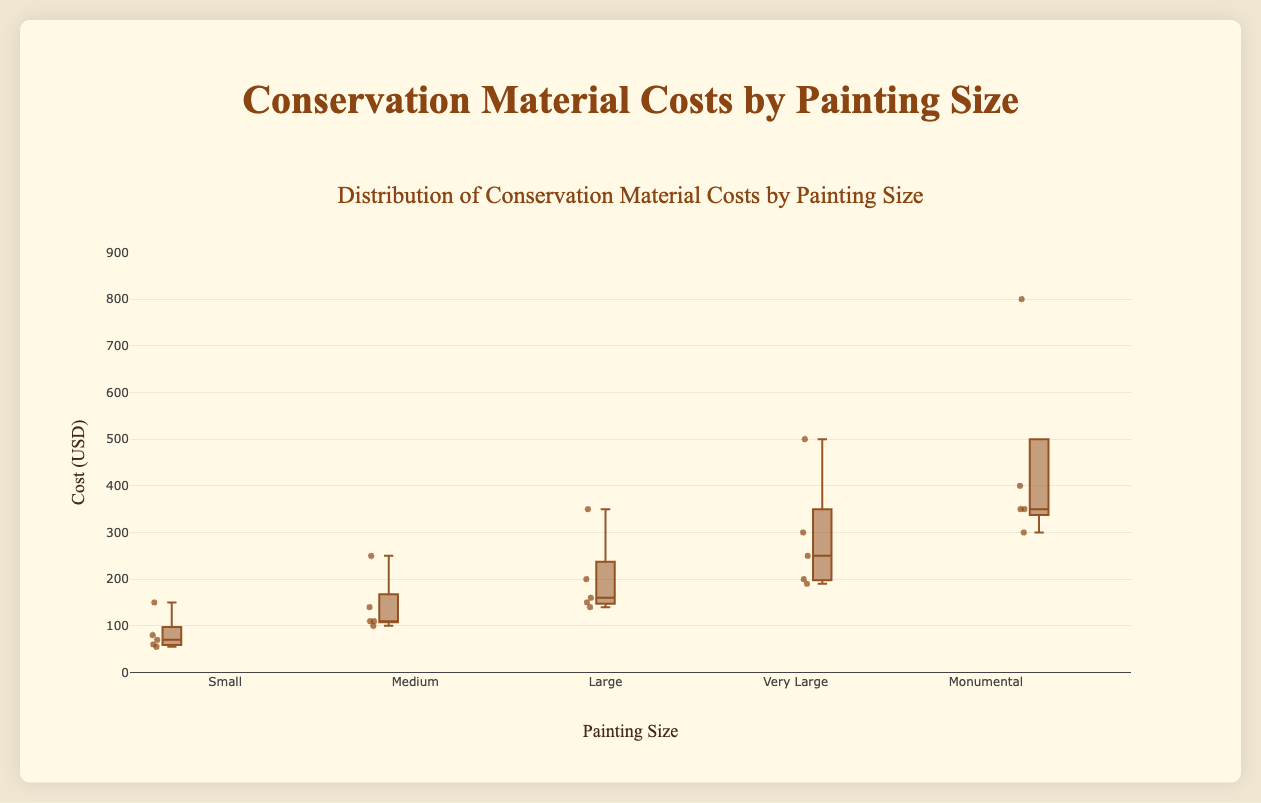How many painting sizes are displayed on the plot? The x-axis of the plot lists five different painting sizes: Small, Medium, Large, Very Large, and Monumental. Each size has its own corresponding box plot.
Answer: 5 Which painting size has the highest median conservation material cost? Looking at the horizontal line inside each box, which represents the median, the Monumental painting size has the highest median line compared to the other sizes.
Answer: Monumental What is the range of costs for the Small painting size? The range of a box plot is determined by the minimum and maximum values indicated by the lower and upper whiskers. For Small, the minimum cost is around 55 and the maximum cost is around 150.
Answer: 55 to 150 What is the general trend in material costs as the painting size increases? As the painting size increases from Small to Monumental, the median and overall range of conservation material costs also increase, showing a positive trend.
Answer: Costs increase with size Compare the interquartile range (IQR) of Medium and Very Large painting sizes. The IQR is the box part of the plot, representing the middle 50% of the data. For Medium, it ranges from about 100 to 250, which is 150. For Very Large, it ranges from about 190 to 500, which is 310.
Answer: Very Large's IQR is larger Which painting size has the most outliers? The number of individual points outside the whiskers of each box plot indicates the outliers. By observing the plot, the Medium painting size has the most outliers compared to other sizes.
Answer: Medium Is there a painting size where the cost does not vary much? By analyzing the height of the boxes and the distance between whiskers, the Small painting size has the shortest range and less variation in costs compared to other sizes.
Answer: Small What is the median cost difference between Large and Small painting sizes? The median cost for Large is near 200 and for Small is near 80. The difference is 200 - 80 = 120.
Answer: 120 Identify the painting size with the largest overall range of costs. The overall range includes all data points from the minimum to the maximum value. The Monumental painting size has the widest spread from around 300 to 800.
Answer: Monumental What would the cost distribution suggest about choosing materials for a Large painting in comparison to a Small painting? Large paintings generally have higher median costs and a wider range of costs than Small paintings, suggesting that conservation materials for large paintings tend to be more expensive and varied. This could influence selection based on budget and specific material needs.
Answer: Larger paintings using more expensive materials 